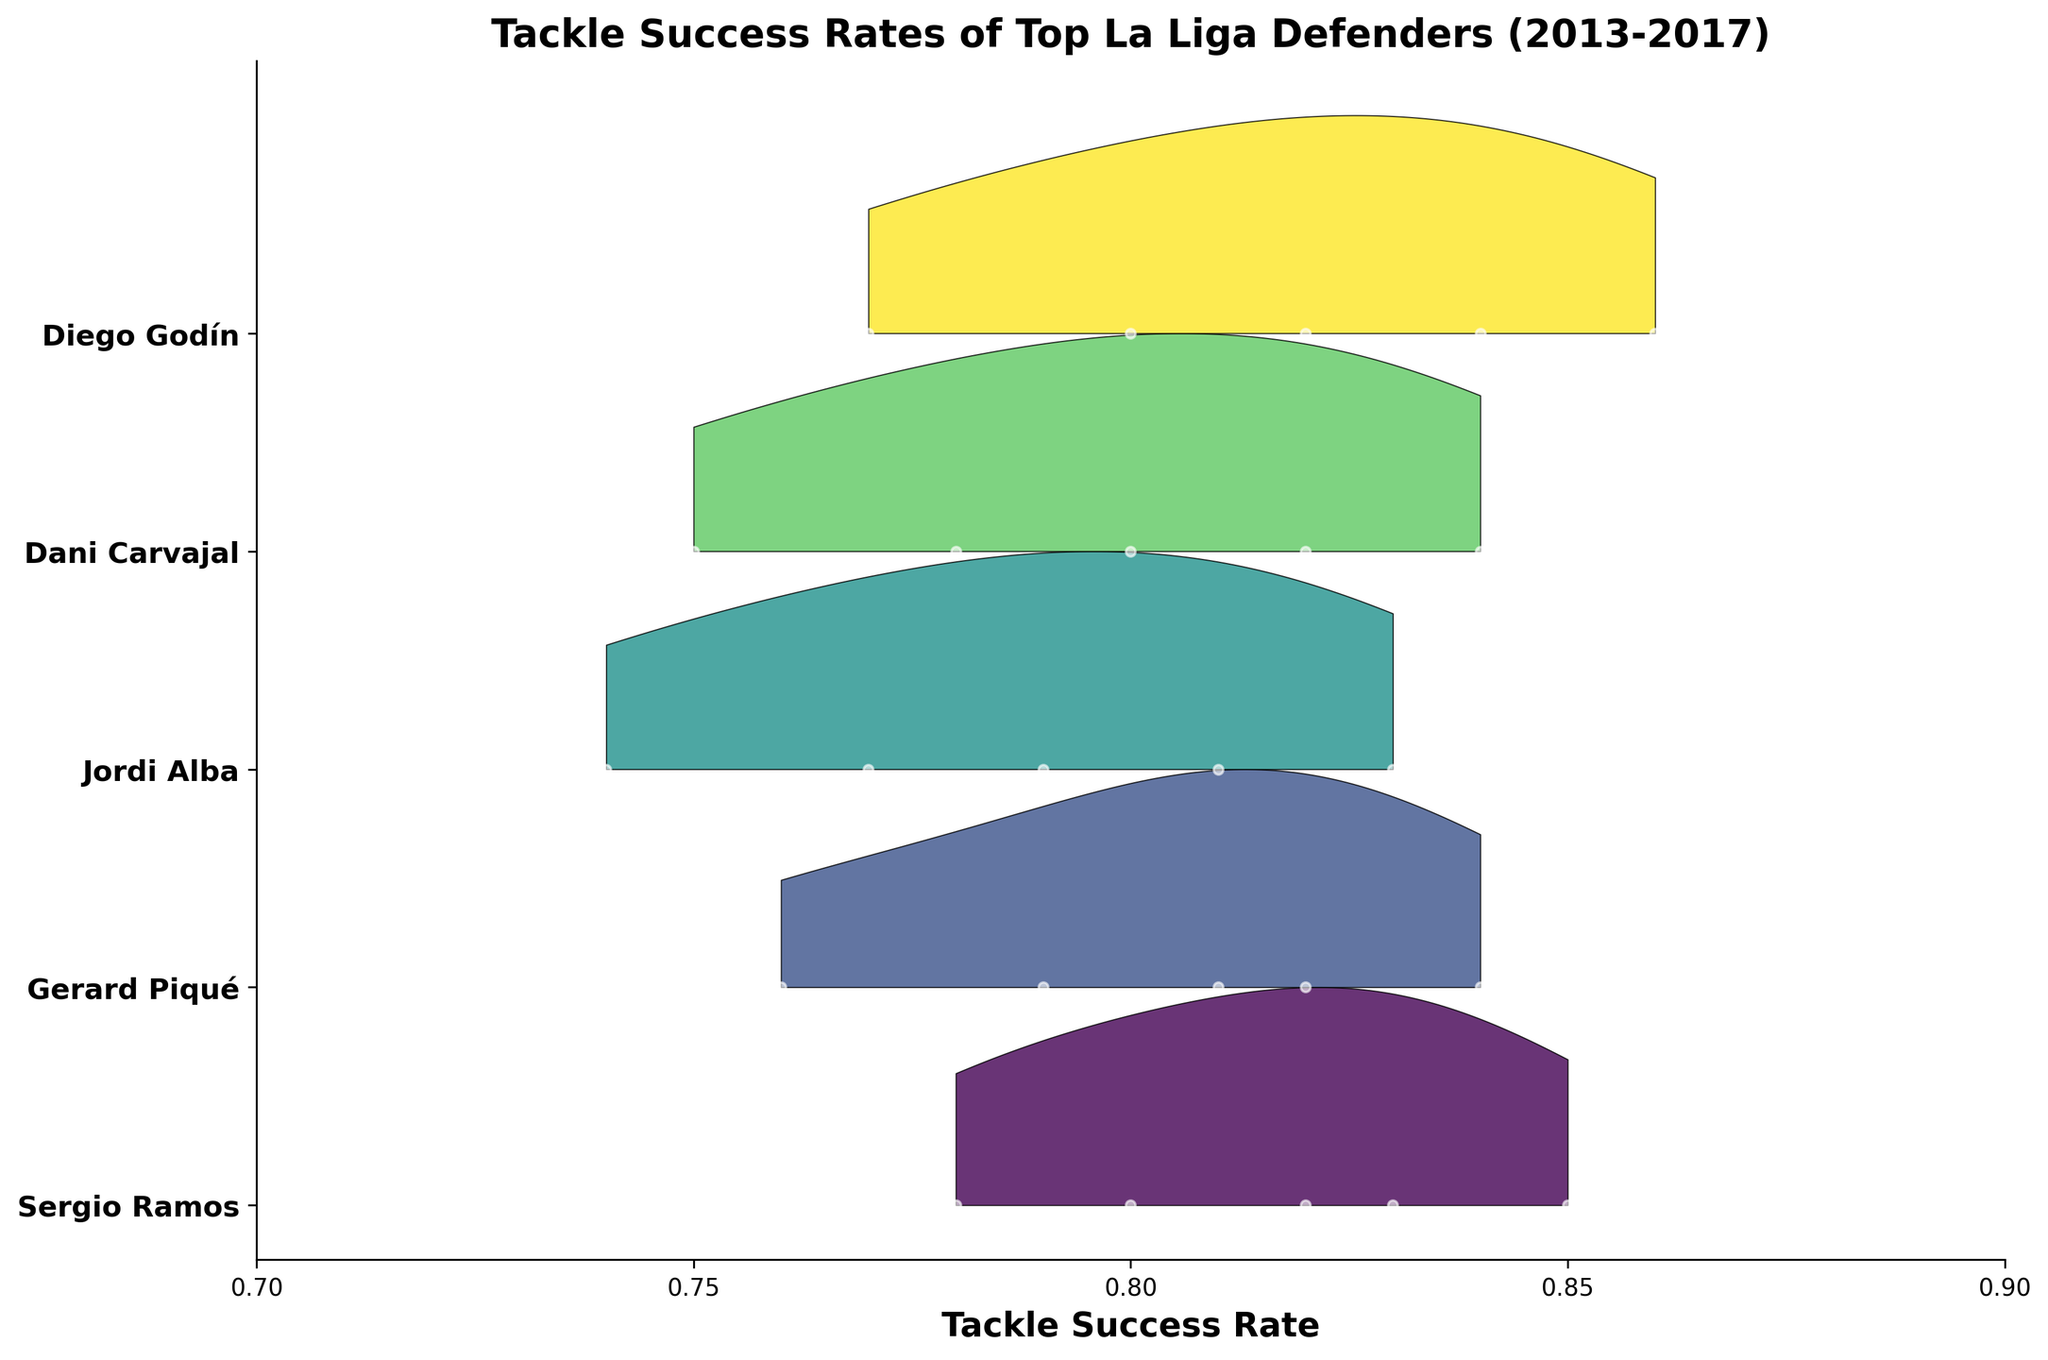Which player had the highest tackle success rate in 2017? To determine the player with the highest tackle success rate in 2017, look at the peaks of the curves for each player corresponding to 2017. Diego Godín's peak is the highest.
Answer: Diego Godín Which player showed the most improvement in tackle success rate between 2013 and 2017? Calculate the difference in tackle success rates between 2013 and 2017 for each player. Diego Godín improved from 0.77 in 2013 to 0.86 in 2017, an increase of 0.09, which is the largest improvement.
Answer: Diego Godín What is the range of tackle success rates for Sergio Ramos across the given years? The minimum and maximum tackle success rates for Sergio Ramos from 2013 to 2017 are 0.78 and 0.85, respectively. The range is the difference between these values. So, 0.85 - 0.78 = 0.07.
Answer: 0.07 How does Gerard Piqué's tackle success rate in 2015 compare to that of Dani Carvajal in the same year? Look at the tackle success rates for both players in 2015. Gerard Piqué's rate is 0.81, while Dani Carvajal's rate is 0.80. Therefore, Piqué has a slightly higher success rate.
Answer: Gerard Piqué has a higher tackle success rate Which player has the steadiest increase in tackle success rate from 2013 to 2017? To find the steadiest increase, look for the player whose tack rates form a consistent upward trend. Dani Carvajal's tackle success rates increase steadily from 0.75 to 0.84 across the years.
Answer: Dani Carvajal What is the average tackle success rate for Jordi Alba over these years? Add the tackle success rates of Jordi Alba from 2013 to 2017 and divide by 5. The rates are 0.74, 0.77, 0.79, 0.81, and 0.83. The sum is 3.94, and the average is 3.94 / 5 = 0.788.
Answer: 0.788 Which year shows the highest overall tackle success rate across all players? Identify the year where multiple peaks are at their highest across most players. Examining the plot, 2017 has the highest peaks for most players.
Answer: 2017 Between 2015 and 2017, who improved their tackle success rate the most? Compare the improvement for each player between 2015 and 2017 by subtracting the 2015 rates from the 2017 rates. Diego Godín improved from 0.82 to 0.86, an increase of 0.04, which is the most significant improvement.
Answer: Diego Godín 